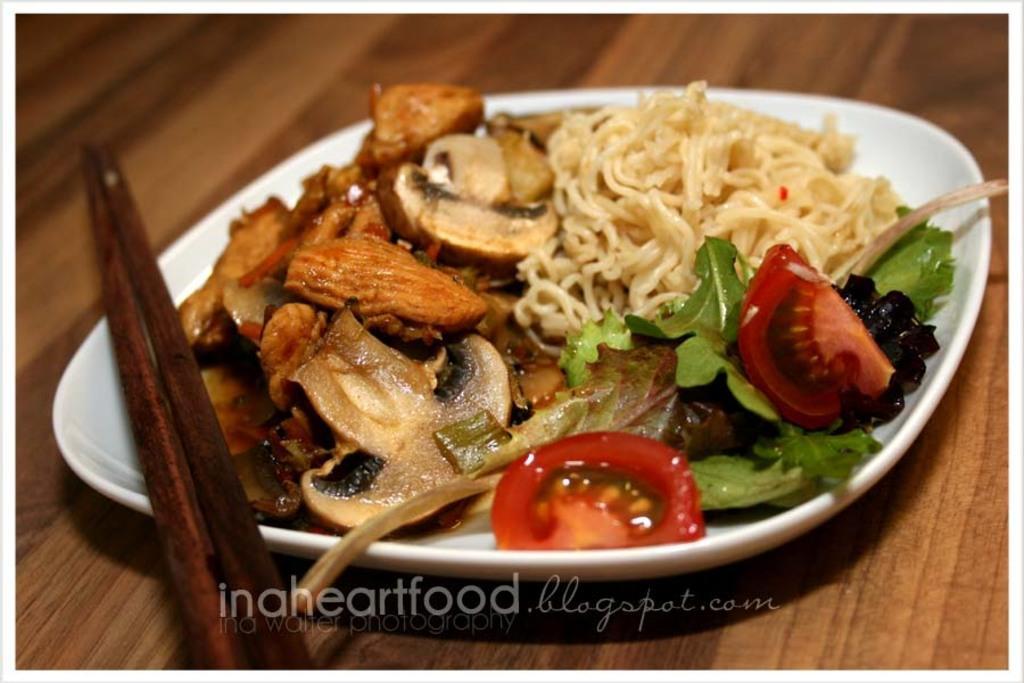Please provide a concise description of this image. In this image I see the white color plate on which there is food which is of brown in color and I see the noodles, tomatoes, mushrooms and the coriander and I see the chopsticks over here and I see the brown color surface and I see the watermark over here. 